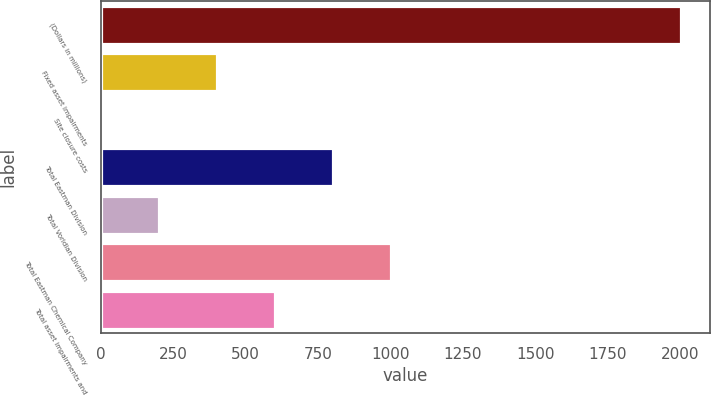Convert chart. <chart><loc_0><loc_0><loc_500><loc_500><bar_chart><fcel>(Dollars in millions)<fcel>Fixed asset impairments<fcel>Site closure costs<fcel>Total Eastman Division<fcel>Total Voridian Division<fcel>Total Eastman Chemical Company<fcel>Total asset impairments and<nl><fcel>2003<fcel>403<fcel>3<fcel>803<fcel>203<fcel>1003<fcel>603<nl></chart> 